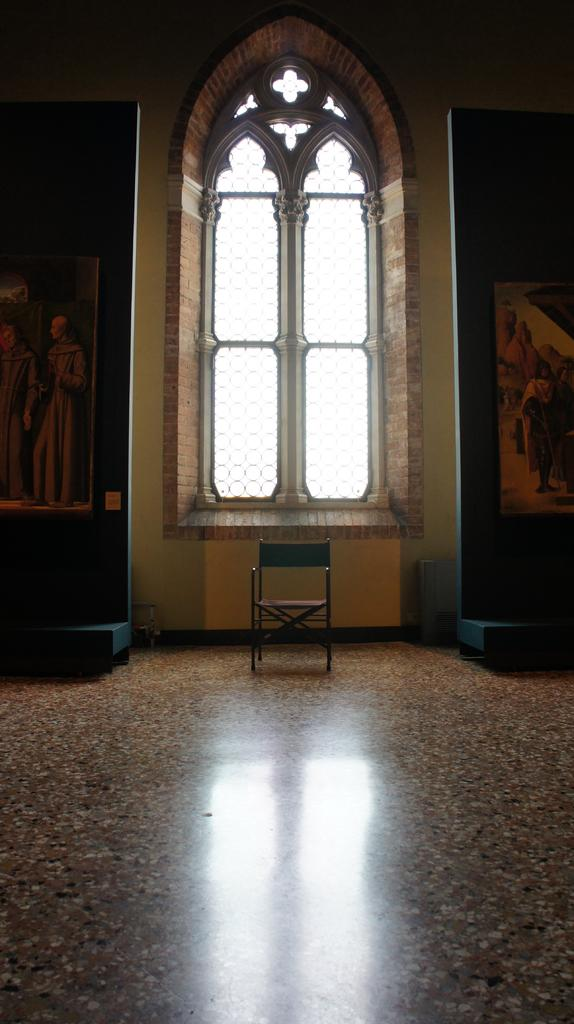What type of location is depicted in the image? The image is an inside view of a building. What architectural feature is visible in the image? There is a window in the image. What type of furniture is present in the image? There is a chair in the image. What objects are placed on the floor in the image? There are frames attached to boards on the floor in the image. Can you see a rifle leaning against the wall in the image? No, there is no rifle present in the image. Is there a bowl of eggnog on the table in the image? There is no table or bowl of eggnog visible in the image. 